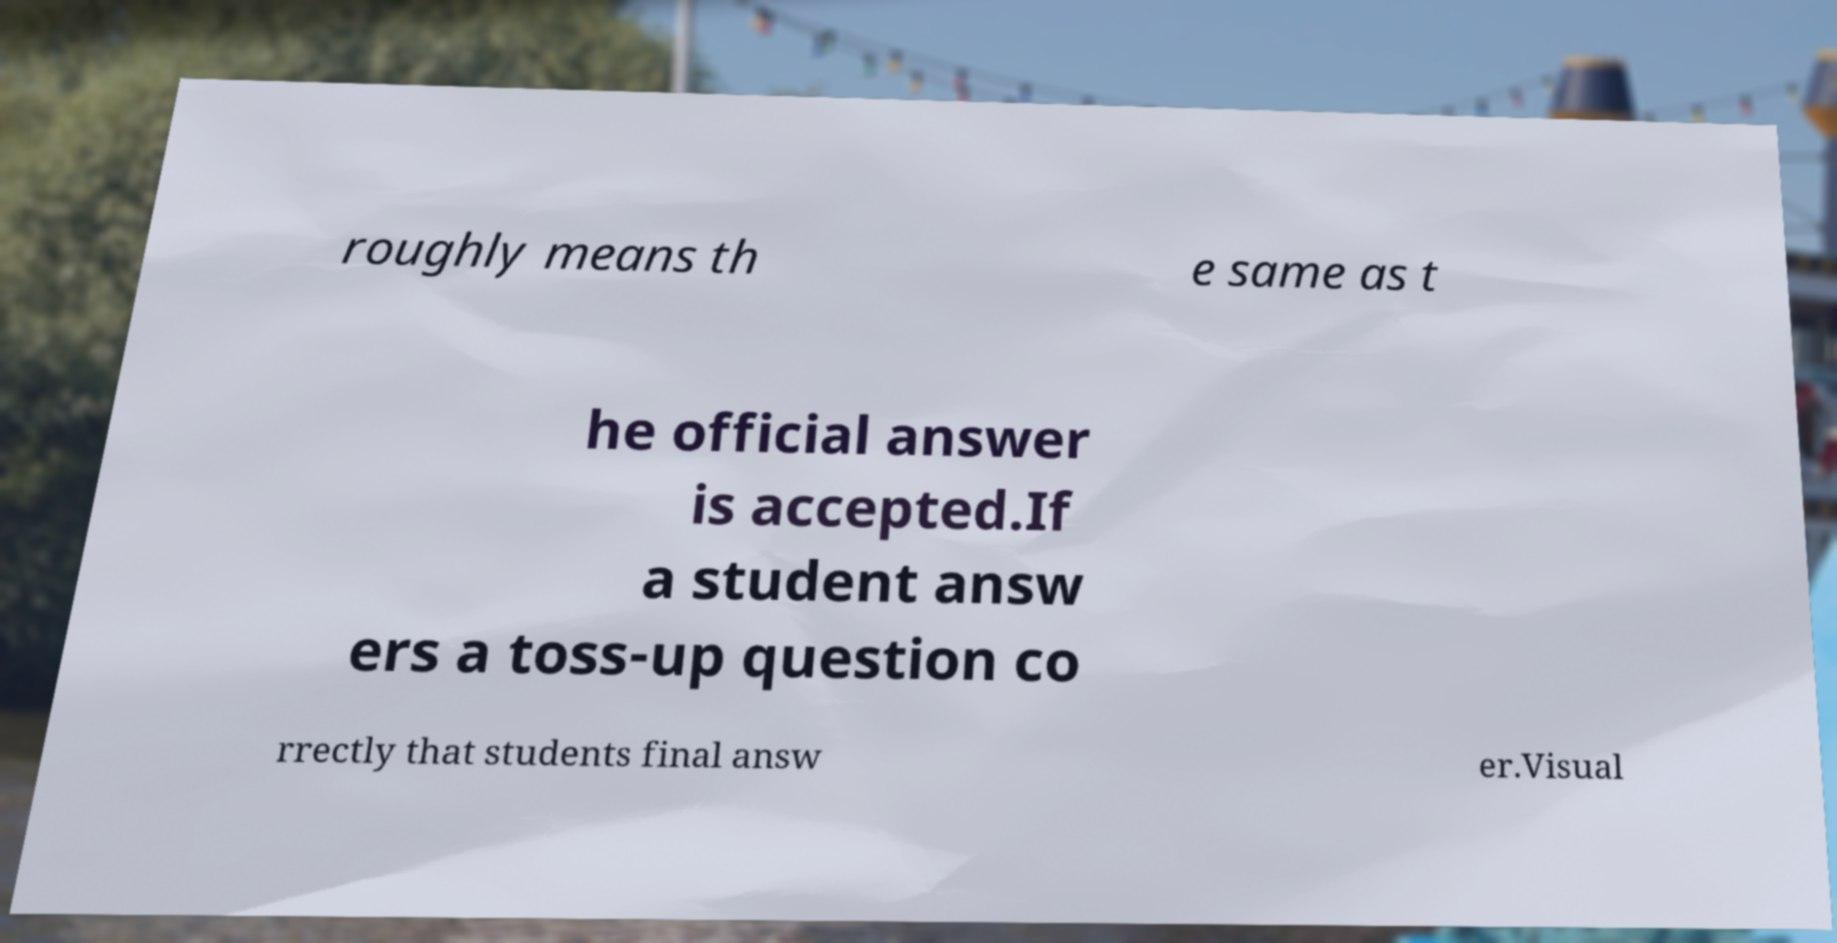Could you assist in decoding the text presented in this image and type it out clearly? roughly means th e same as t he official answer is accepted.If a student answ ers a toss-up question co rrectly that students final answ er.Visual 